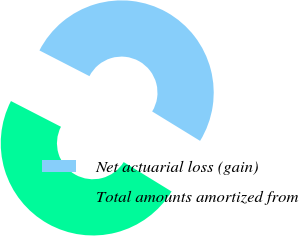Convert chart to OTSL. <chart><loc_0><loc_0><loc_500><loc_500><pie_chart><fcel>Net actuarial loss (gain)<fcel>Total amounts amortized from<nl><fcel>51.2%<fcel>48.8%<nl></chart> 